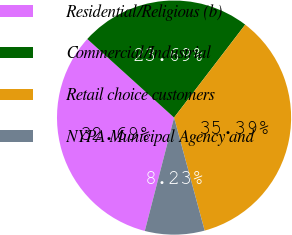Convert chart. <chart><loc_0><loc_0><loc_500><loc_500><pie_chart><fcel>Residential/Religious (b)<fcel>Commercial/Industrial<fcel>Retail choice customers<fcel>NYPA Municipal Agency and<nl><fcel>32.69%<fcel>23.69%<fcel>35.39%<fcel>8.23%<nl></chart> 